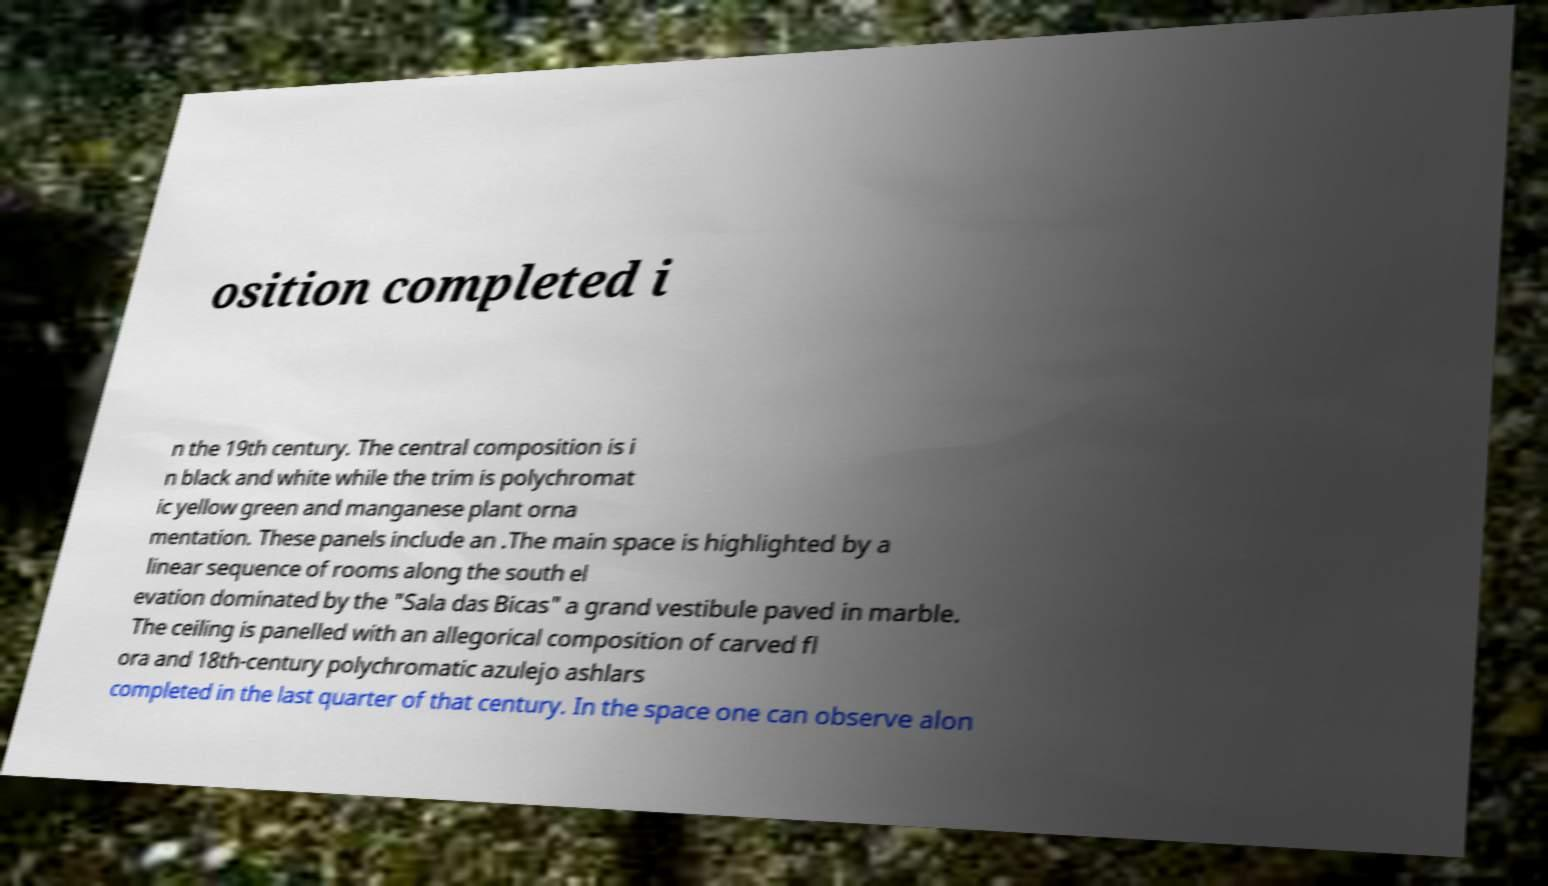Could you assist in decoding the text presented in this image and type it out clearly? osition completed i n the 19th century. The central composition is i n black and white while the trim is polychromat ic yellow green and manganese plant orna mentation. These panels include an .The main space is highlighted by a linear sequence of rooms along the south el evation dominated by the "Sala das Bicas" a grand vestibule paved in marble. The ceiling is panelled with an allegorical composition of carved fl ora and 18th-century polychromatic azulejo ashlars completed in the last quarter of that century. In the space one can observe alon 